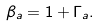Convert formula to latex. <formula><loc_0><loc_0><loc_500><loc_500>\beta _ { a } = 1 + \Gamma _ { a } .</formula> 